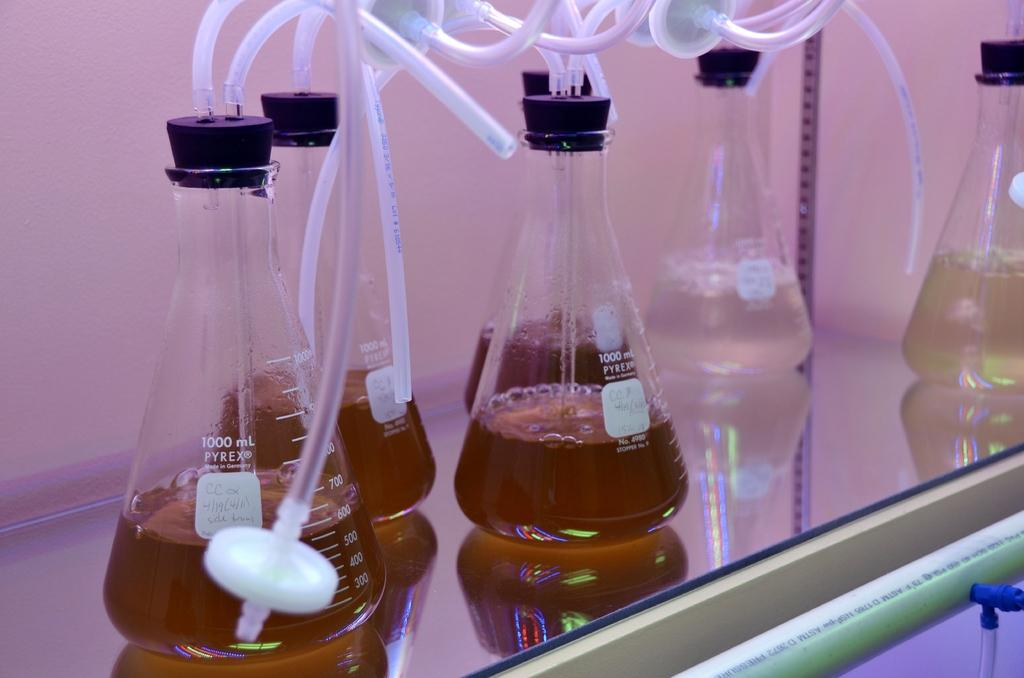<image>
Describe the image concisely. Several beakers with liquids in them and labels that are unreadable. 